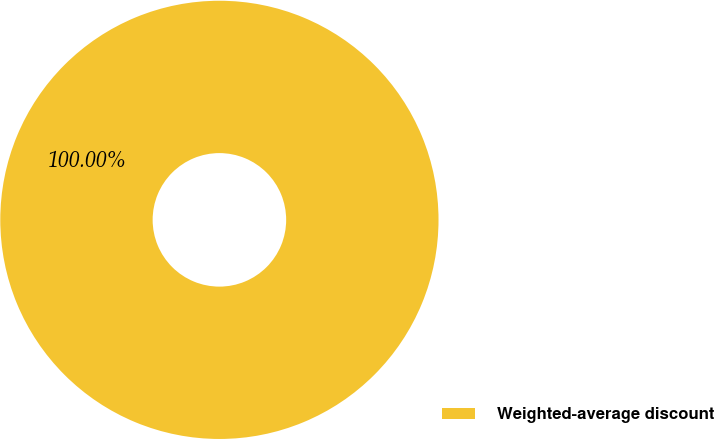<chart> <loc_0><loc_0><loc_500><loc_500><pie_chart><fcel>Weighted-average discount<nl><fcel>100.0%<nl></chart> 